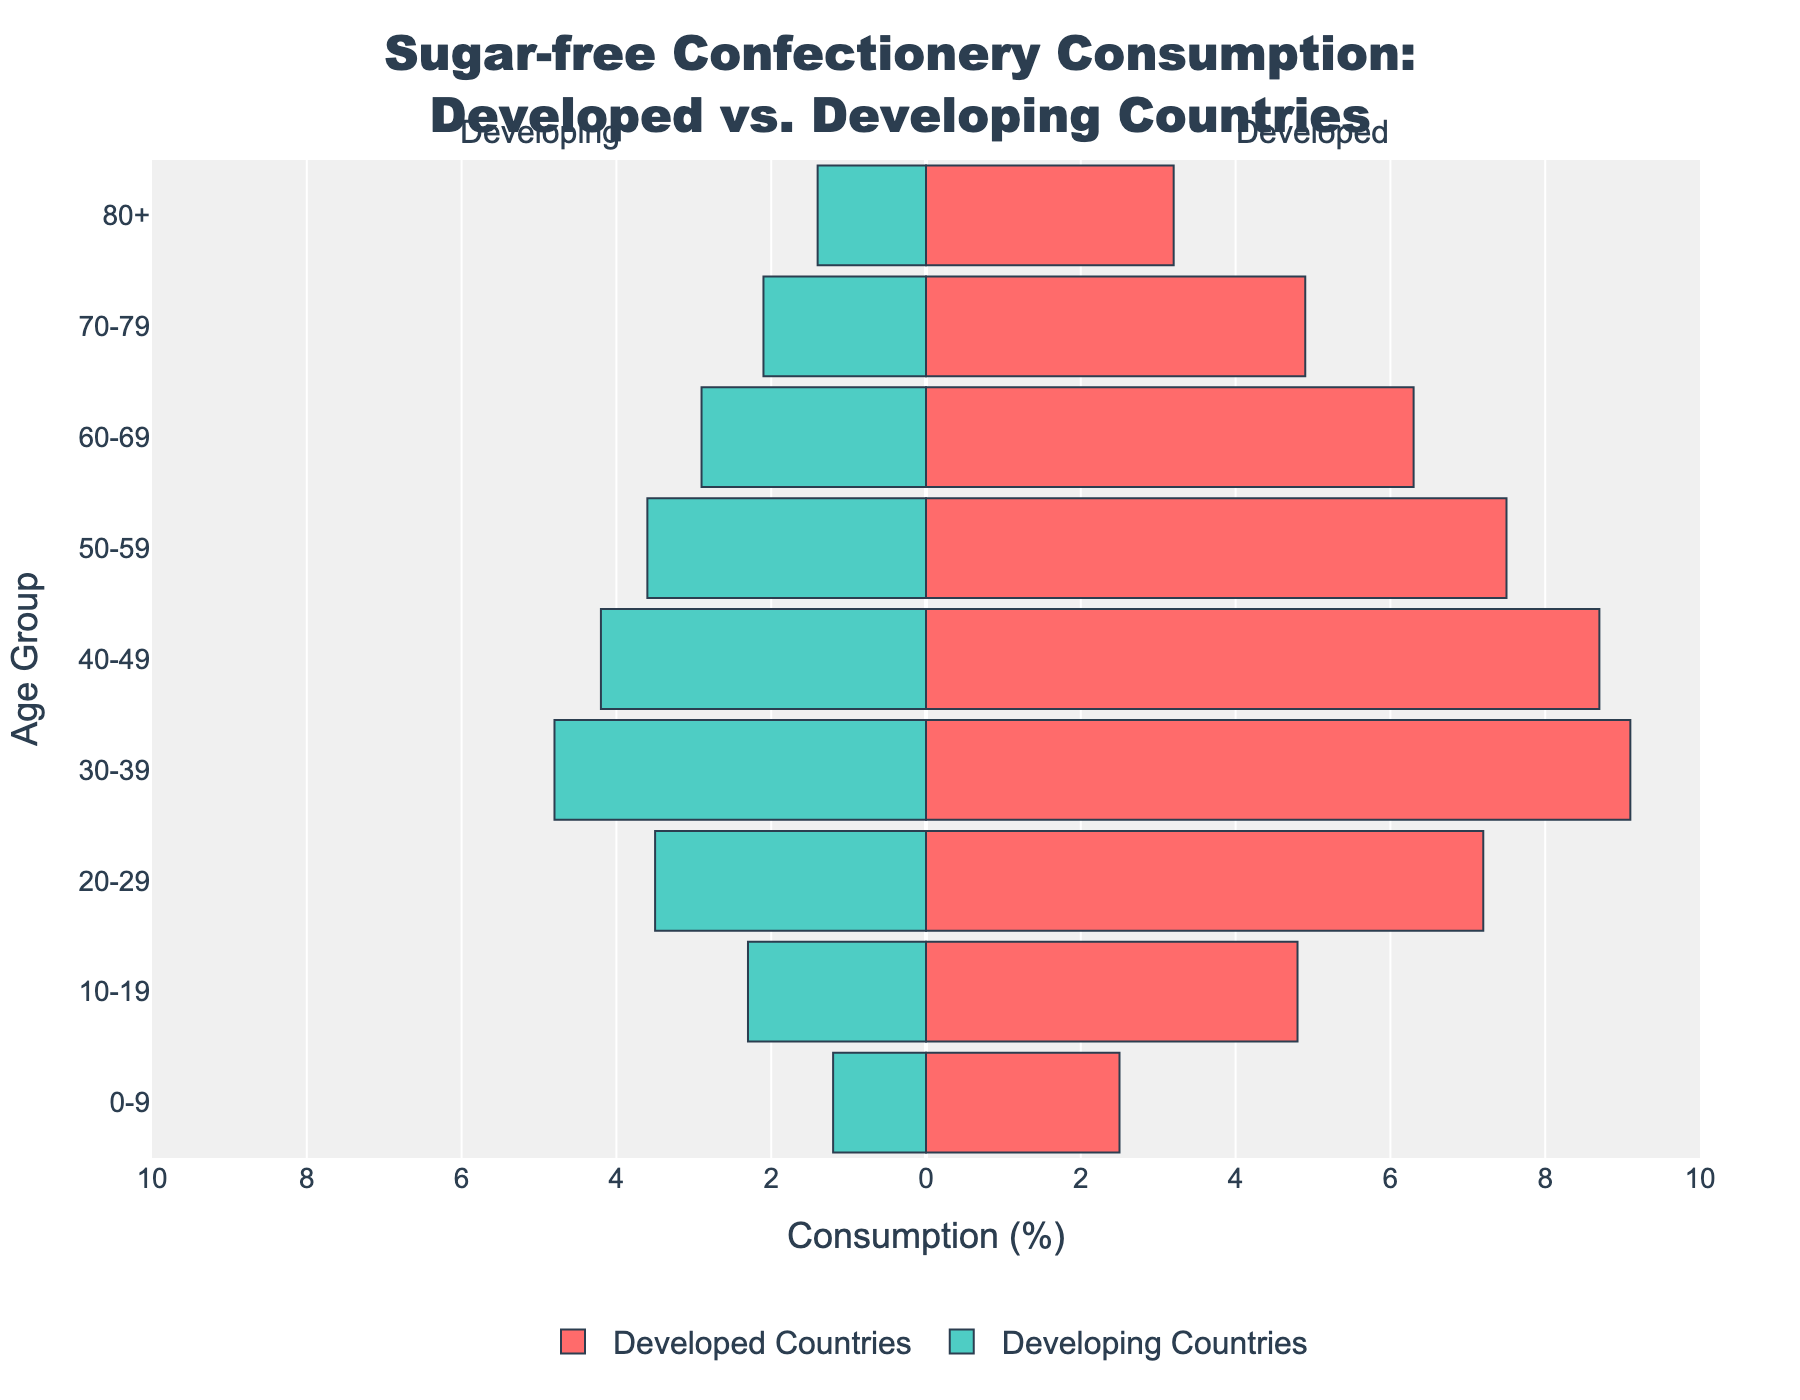Which age group has the highest consumption of sugar-free confectionery in developed countries? The highest bar on the right side represents the age group with the highest consumption. For developed countries, the 30-39 age group has the highest value at 9.1%.
Answer: 30-39 Which age group has the lowest consumption of sugar-free confectionery in developing countries? The lowest bar on the left side represents the age group with the lowest consumption. For developing countries, the 0-9 age group has the lowest value at 1.2%.
Answer: 0-9 What's the difference in sugar-free confectionery consumption between the age group 30-39 and 40-49 in developed countries? The bar segments for 30-39 and 40-49 in developed countries are compared. For developed countries, 30-39 is at 9.1% and 40-49 is at 8.7%. The difference is 9.1% - 8.7% = 0.4%.
Answer: 0.4% What is the title of the plot? The title is displayed at the top of the plot. It reads 'Sugar-free Confectionery Consumption: Developed vs. Developing Countries'.
Answer: Sugar-free Confectionery Consumption: Developed vs. Developing Countries Which age group consumes more sugar-free confectionery: 60-69 in developed countries or 20-29 in developing countries? Compare the bar lengths for the 60-69 group in developed countries and the 20-29 group in developing countries. The 60-69 group in developed countries has a value of 6.3%, whereas the 20-29 group in developing countries has a value of 3.5%.
Answer: 60-69 in developed countries How does the sugar-free confectionery consumption trend change across age groups in developed countries? The bars in developed countries from age group 0-9 to 80+ show an increasing trend up to age group 30-39, then a gradual decrease.
Answer: Increases to 30-39, then decreases By how much does the sugar-free confectionery consumption in age group 70-79 differ between developed and developing countries? Compare the bar lengths for 70-79 in both sides. The developed countries show 4.9%, while developing countries have 2.1%. The difference is 4.9% - 2.1% = 2.8%.
Answer: 2.8% What color represents the developed countries in the plot? The bars representing developed countries are colored in a shade of red.
Answer: Red What is the range of percentages shown on the x-axis? The x-axis displaying consumption percentages ranges from -10% to 10%.
Answer: -10% to 10% In which age group is the difference in sugar-free confectionery consumption largest between developed and developing countries? To find the largest difference, compare the differences across all age groups. The largest difference is in the 30-39 group, where developed countries' consumption is 9.1% and developing countries' is 4.8%, making the difference 9.1% - 4.8% = 4.3%.
Answer: 30-39 